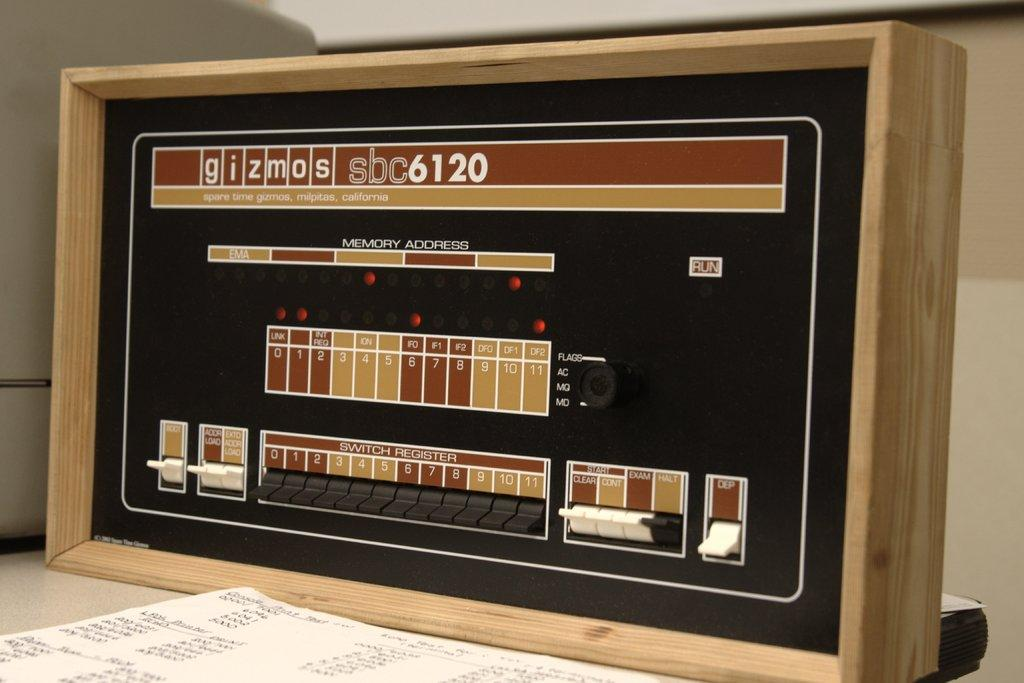<image>
Share a concise interpretation of the image provided. The control panel for a Gizmos sbc 6120. 